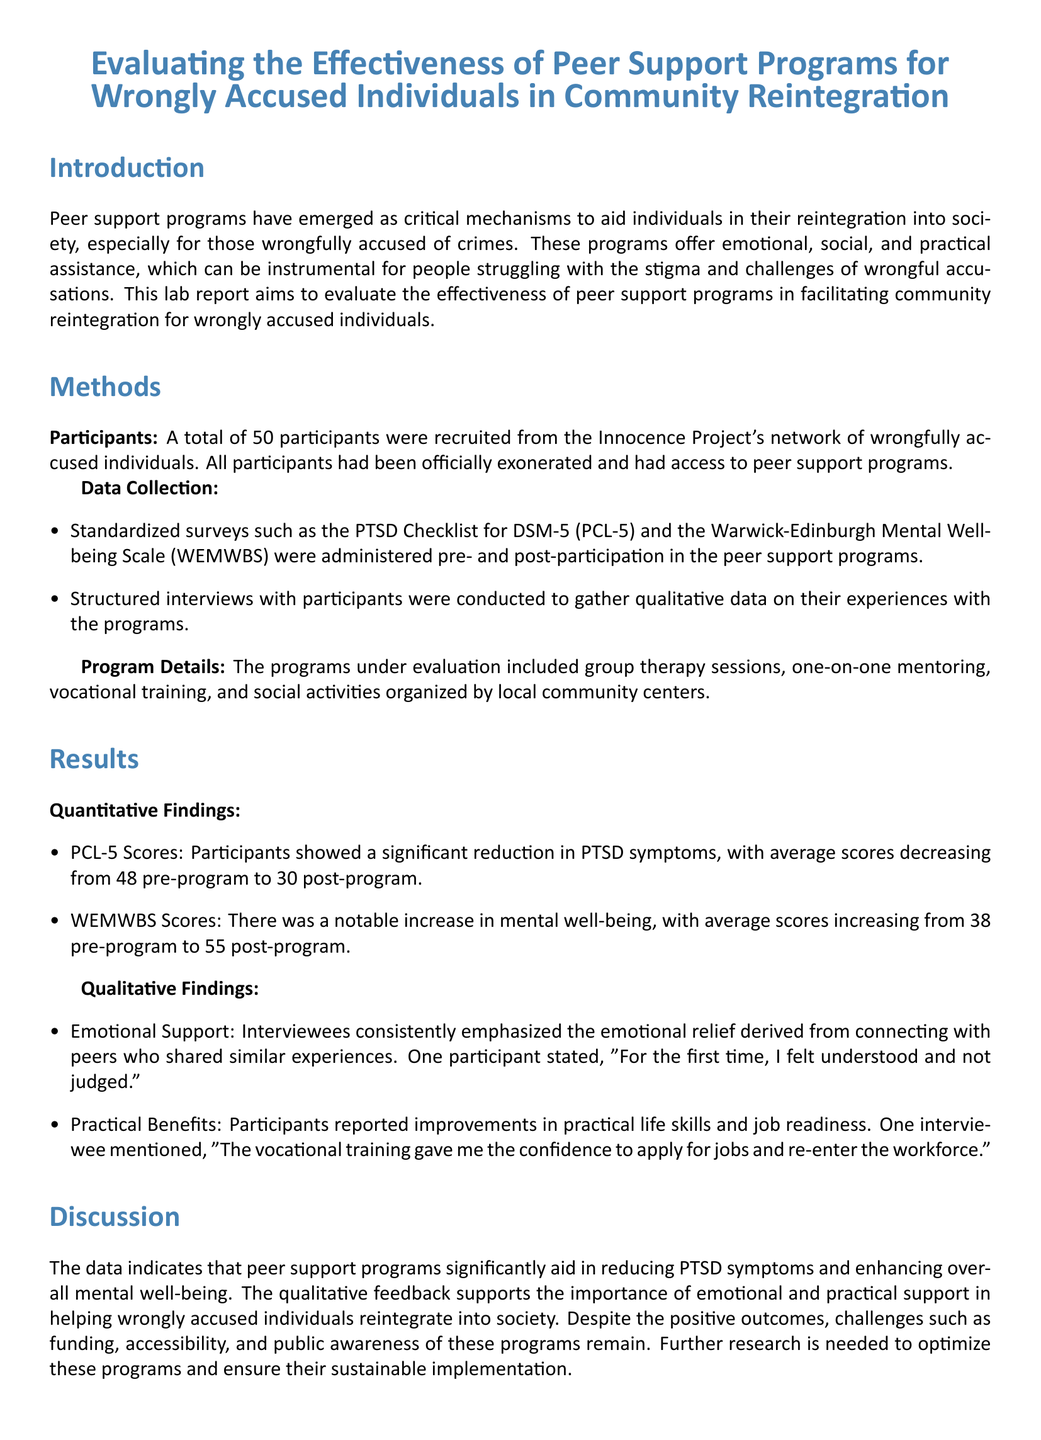What is the sample size of participants in the study? The number of participants is specified in the Methods section, totaling 50 individuals.
Answer: 50 What were the two standardized surveys used for data collection? The two surveys mentioned in the Methods section are the PTSD Checklist for DSM-5 and the Warwick-Edinburgh Mental Well-being Scale.
Answer: PCL-5 and WEMWBS What was the average pre-program PCL-5 score? The average score is provided in the Results section, indicating a pre-program score of 48.
Answer: 48 How much did WEMWBS scores increase after the program? The change in average WEMWBS scores is noted in the Results section, specifically an increase from 38 to 55.
Answer: 17 What type of training did participants report receiving benefits from? The document specifically mentions vocational training as a practical benefit reported by participants.
Answer: Vocational training What did participants emphasize as an important aspect of their peer support experience? The qualitative findings highlight the emotional relief provided by peer connections as a key theme from participant interviews.
Answer: Emotional Support What is a challenge mentioned regarding peer support programs? The Discussion section identifies challenges such as funding, accessibility, and public awareness as obstacles to the programs.
Answer: Funding What type of document is this? The structure and content indicate that this document is a lab report focusing on research and evaluation.
Answer: Lab report 